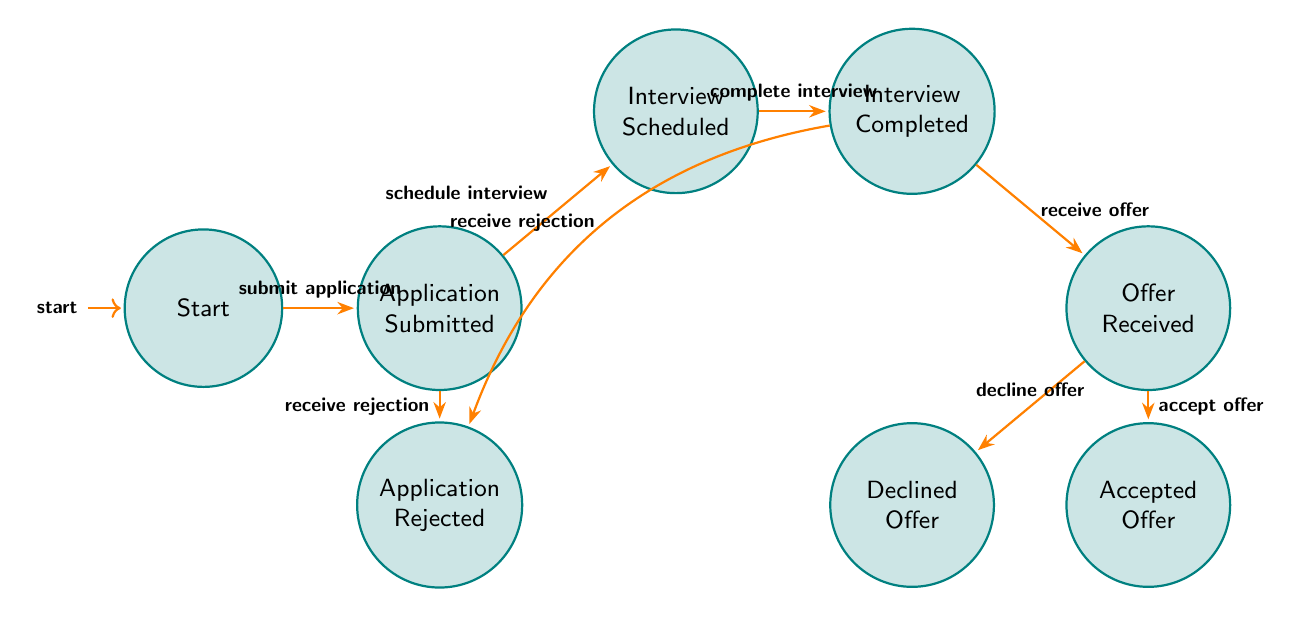What is the initial state of the diagram? The initial state is labeled as "Start". This is the first node where the job application process begins, and it is marked as the entry point of the finite state machine.
Answer: Start How many states are there in total? The diagram lists eight distinct states: Start, Application Submitted, Interview Scheduled, Interview Completed, Offer Received, Application Rejected, Accepted Offer, and Declined Offer. Counting these gives a total of eight states in the finite state machine.
Answer: 8 What transition occurs after "Application Submitted"? After the state "Application Submitted", the transition that follows is "schedule interview", moving to the state "Interview Scheduled". This indicates the action taken next in the job application process.
Answer: Interview Scheduled Which state leads to both "Accepted Offer" and "Declined Offer"? The state "Offer Received" leads to both "Accepted Offer" and "Declined Offer". This means that once an offer is received, the applicant has the option to either accept or decline that offer.
Answer: Offer Received What happens if the application is rejected after submission? If the application is rejected after submission, the state will transition from "Application Submitted" to "Application Rejected". This indicates the final state in the process where the applicant learns that their application has not been successful.
Answer: Application Rejected How many transitions originate from "Interview Completed"? There are two transitions that originate from the state "Interview Completed": one leading to "Offer Received" and the other leading to "Application Rejected". This shows that after an interview, the outcome can either be an offer or a rejection.
Answer: 2 What is the final state if the offer is accepted? If the offer is accepted, the final state of the process is "Accepted Offer". This indicates a successful outcome where the applicant has agreed to take the job offer.
Answer: Accepted Offer What action leads to the "Interview Completed" state? The action that leads to the "Interview Completed" state is "complete interview". This transition signifies that the interview process for the job has been finished.
Answer: complete interview 